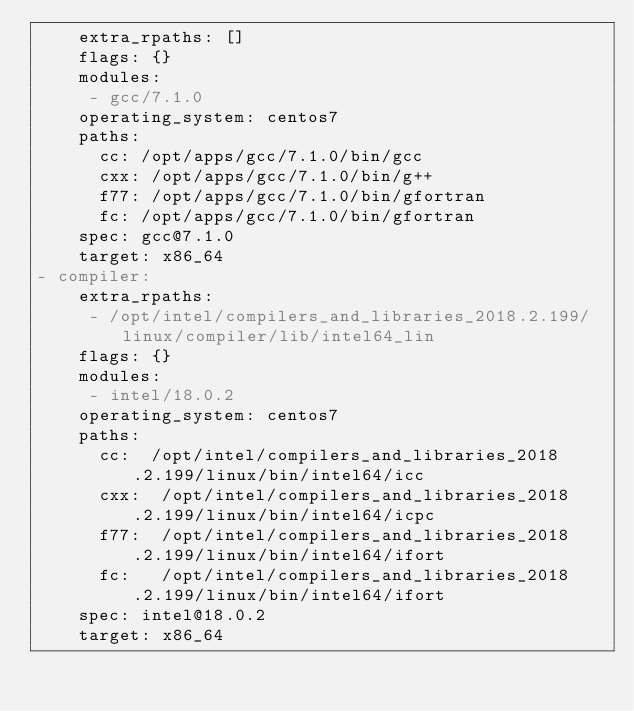<code> <loc_0><loc_0><loc_500><loc_500><_YAML_>    extra_rpaths: []
    flags: {}
    modules:
     - gcc/7.1.0
    operating_system: centos7
    paths:
      cc: /opt/apps/gcc/7.1.0/bin/gcc
      cxx: /opt/apps/gcc/7.1.0/bin/g++
      f77: /opt/apps/gcc/7.1.0/bin/gfortran
      fc: /opt/apps/gcc/7.1.0/bin/gfortran
    spec: gcc@7.1.0
    target: x86_64
- compiler:
    extra_rpaths:
     - /opt/intel/compilers_and_libraries_2018.2.199/linux/compiler/lib/intel64_lin
    flags: {}
    modules:
     - intel/18.0.2
    operating_system: centos7
    paths:
      cc:  /opt/intel/compilers_and_libraries_2018.2.199/linux/bin/intel64/icc
      cxx:  /opt/intel/compilers_and_libraries_2018.2.199/linux/bin/intel64/icpc
      f77:  /opt/intel/compilers_and_libraries_2018.2.199/linux/bin/intel64/ifort
      fc:   /opt/intel/compilers_and_libraries_2018.2.199/linux/bin/intel64/ifort
    spec: intel@18.0.2
    target: x86_64
</code> 